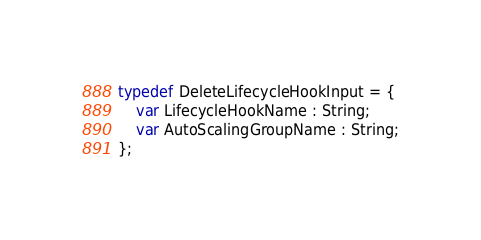<code> <loc_0><loc_0><loc_500><loc_500><_Haxe_>typedef DeleteLifecycleHookInput = {
    var LifecycleHookName : String;
    var AutoScalingGroupName : String;
};
</code> 